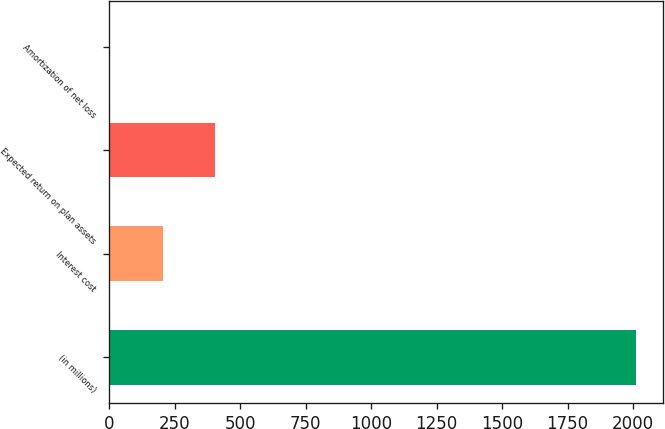<chart> <loc_0><loc_0><loc_500><loc_500><bar_chart><fcel>(in millions)<fcel>Interest cost<fcel>Expected return on plan assets<fcel>Amortization of net loss<nl><fcel>2013<fcel>204.9<fcel>405.8<fcel>4<nl></chart> 